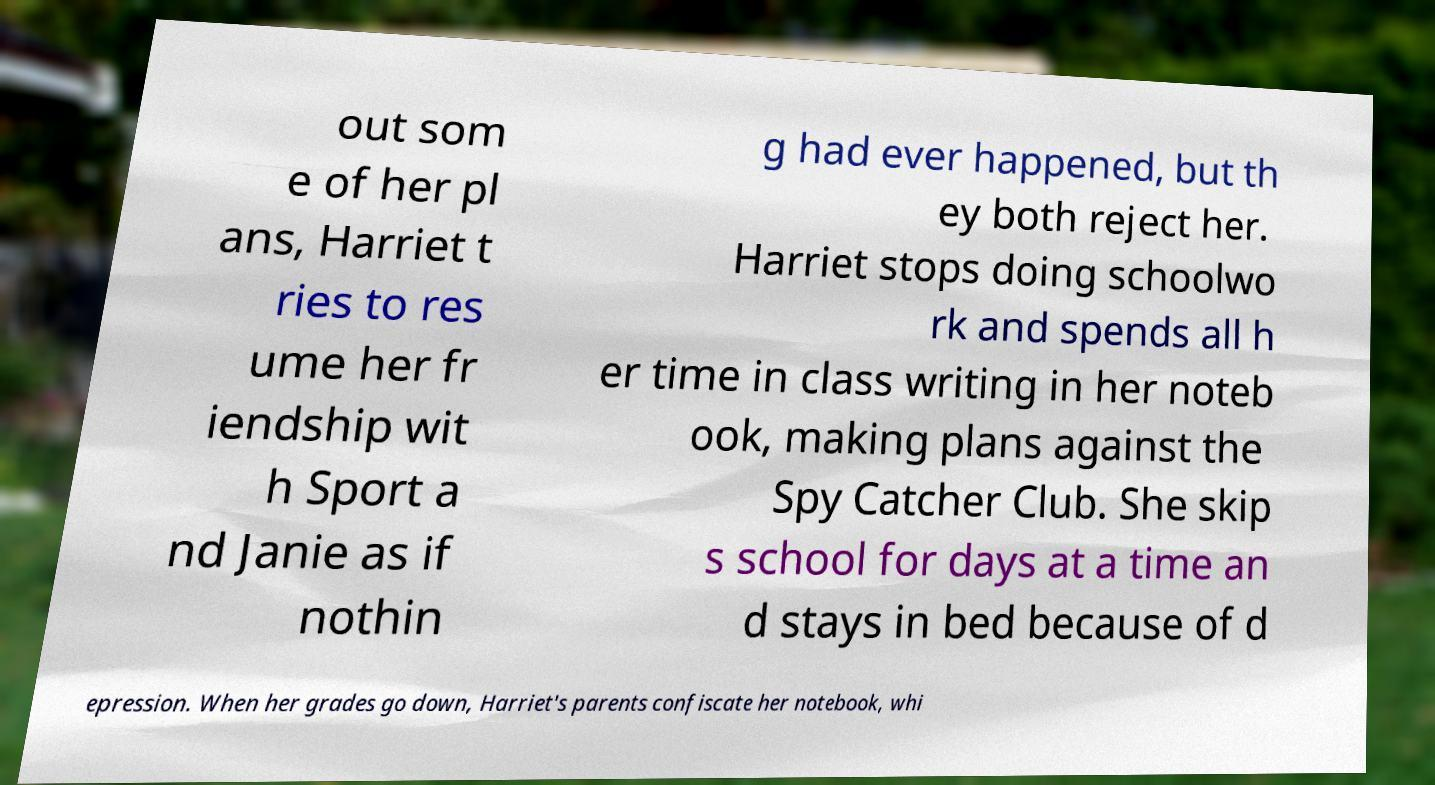Please identify and transcribe the text found in this image. out som e of her pl ans, Harriet t ries to res ume her fr iendship wit h Sport a nd Janie as if nothin g had ever happened, but th ey both reject her. Harriet stops doing schoolwo rk and spends all h er time in class writing in her noteb ook, making plans against the Spy Catcher Club. She skip s school for days at a time an d stays in bed because of d epression. When her grades go down, Harriet's parents confiscate her notebook, whi 